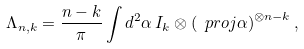Convert formula to latex. <formula><loc_0><loc_0><loc_500><loc_500>\Lambda _ { n , k } = \frac { n - k } { \pi } \int d ^ { 2 } \alpha \, I _ { k } \otimes \left ( \ p r o j { \alpha } \right ) ^ { \otimes n - k } ,</formula> 